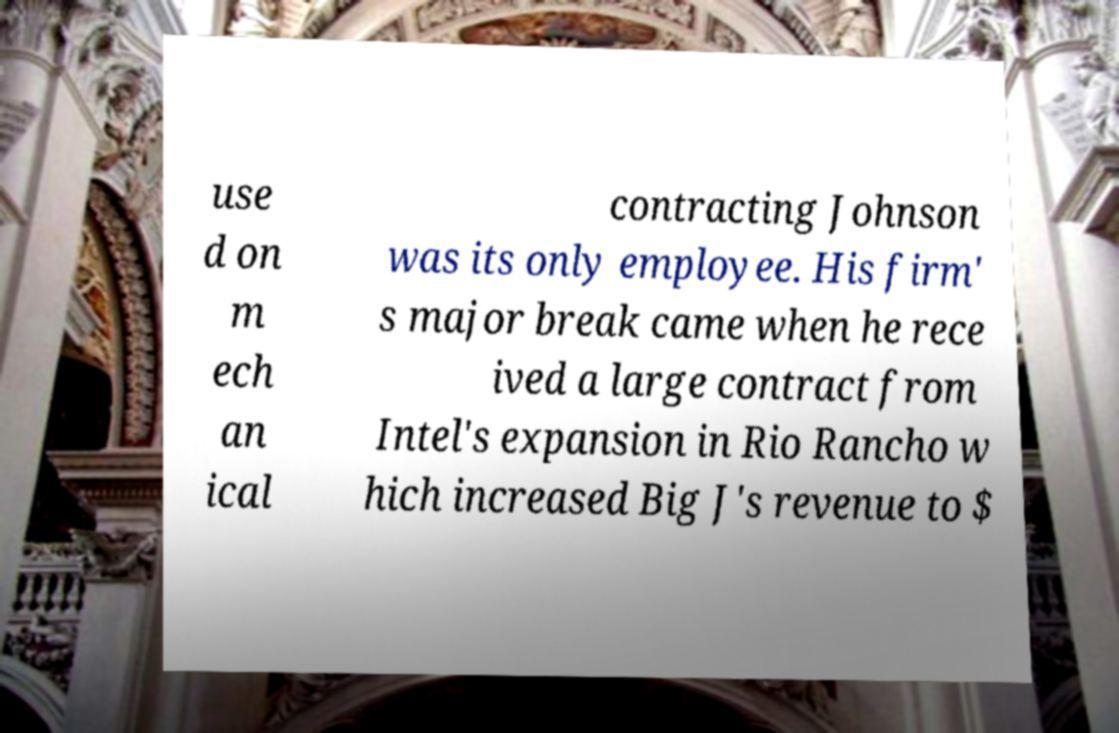Could you extract and type out the text from this image? use d on m ech an ical contracting Johnson was its only employee. His firm' s major break came when he rece ived a large contract from Intel's expansion in Rio Rancho w hich increased Big J's revenue to $ 